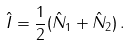<formula> <loc_0><loc_0><loc_500><loc_500>\hat { I } = \frac { 1 } { 2 } ( \hat { N } _ { 1 } + \hat { N } _ { 2 } ) \, .</formula> 